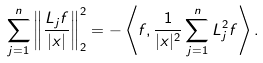<formula> <loc_0><loc_0><loc_500><loc_500>\sum _ { j = 1 } ^ { n } \left \| \frac { L _ { j } f } { | x | } \right \| _ { 2 } ^ { 2 } & = - \left \langle f , \frac { 1 } { | x | ^ { 2 } } \sum _ { j = 1 } ^ { n } L _ { j } ^ { 2 } f \right \rangle .</formula> 